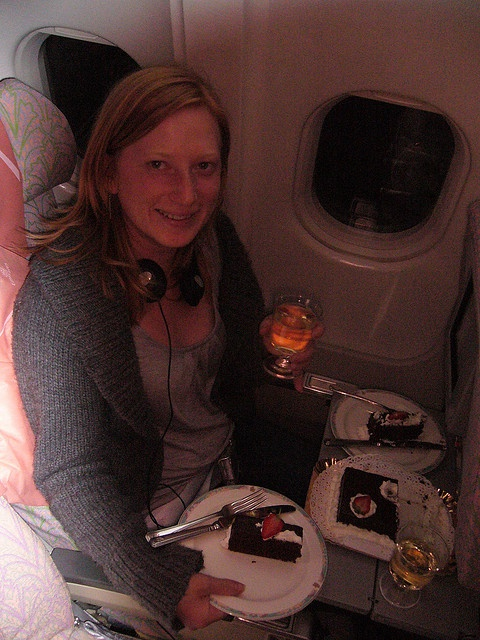Describe the objects in this image and their specific colors. I can see people in gray, black, and maroon tones, cake in gray, black, brown, and maroon tones, wine glass in gray, maroon, black, and brown tones, cake in gray, black, maroon, and brown tones, and wine glass in gray, maroon, black, and brown tones in this image. 